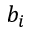<formula> <loc_0><loc_0><loc_500><loc_500>b _ { i }</formula> 